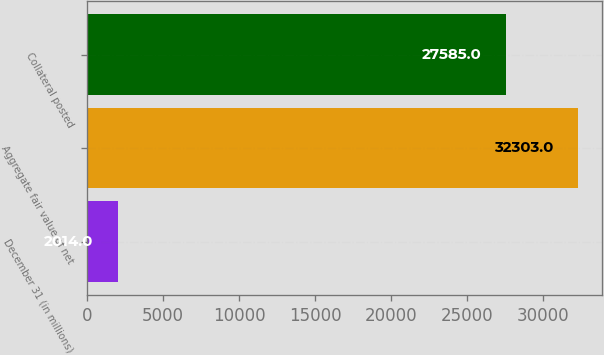<chart> <loc_0><loc_0><loc_500><loc_500><bar_chart><fcel>December 31 (in millions)<fcel>Aggregate fair value of net<fcel>Collateral posted<nl><fcel>2014<fcel>32303<fcel>27585<nl></chart> 